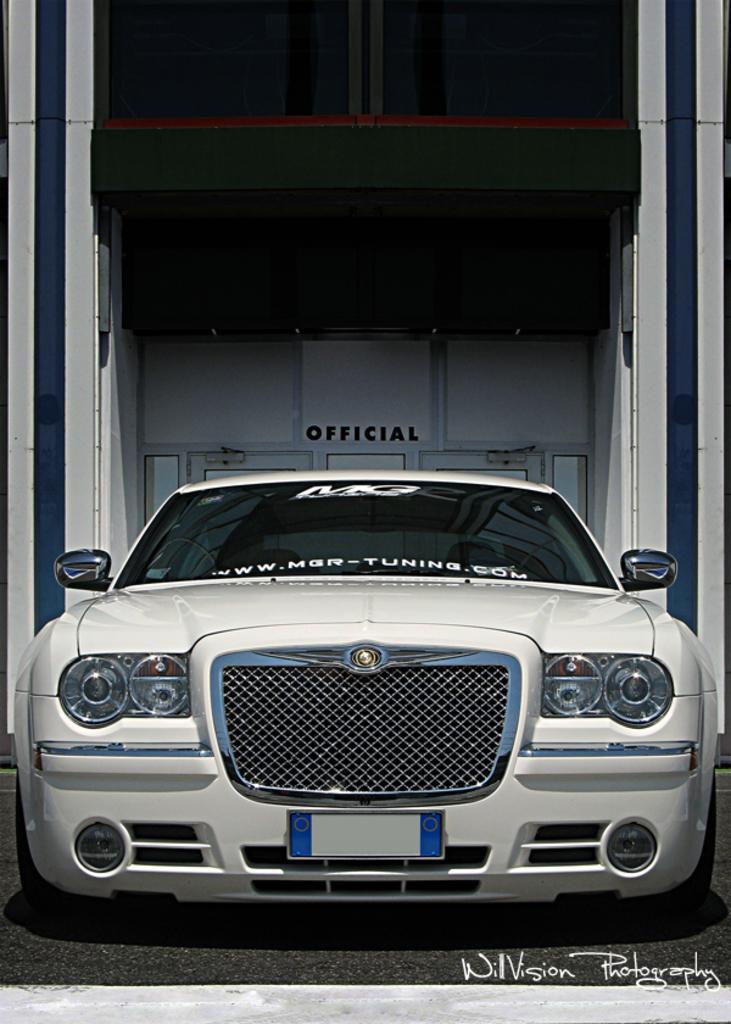Can you describe this image briefly? This image consists of a car which is in white color. Behind that there is "Official" written on the wall. This car has headlights, mirrors ,number plate. 